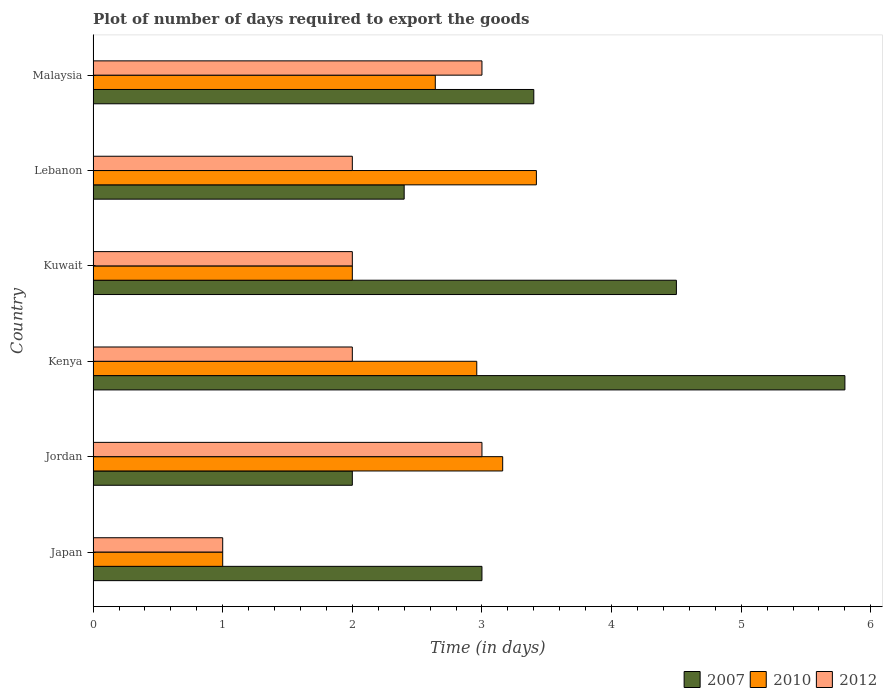Are the number of bars per tick equal to the number of legend labels?
Make the answer very short. Yes. How many bars are there on the 3rd tick from the bottom?
Your answer should be compact. 3. What is the label of the 6th group of bars from the top?
Your answer should be very brief. Japan. What is the time required to export goods in 2012 in Kenya?
Keep it short and to the point. 2. Across all countries, what is the maximum time required to export goods in 2007?
Offer a very short reply. 5.8. Across all countries, what is the minimum time required to export goods in 2007?
Your answer should be compact. 2. In which country was the time required to export goods in 2007 maximum?
Offer a very short reply. Kenya. In which country was the time required to export goods in 2007 minimum?
Offer a terse response. Jordan. What is the total time required to export goods in 2010 in the graph?
Make the answer very short. 15.18. What is the difference between the time required to export goods in 2007 in Kuwait and that in Lebanon?
Your answer should be very brief. 2.1. What is the difference between the time required to export goods in 2012 in Jordan and the time required to export goods in 2010 in Lebanon?
Give a very brief answer. -0.42. What is the average time required to export goods in 2007 per country?
Make the answer very short. 3.52. What is the difference between the time required to export goods in 2010 and time required to export goods in 2007 in Malaysia?
Your response must be concise. -0.76. In how many countries, is the time required to export goods in 2012 greater than 0.8 days?
Your response must be concise. 6. What is the ratio of the time required to export goods in 2007 in Japan to that in Kuwait?
Your answer should be compact. 0.67. Is the difference between the time required to export goods in 2010 in Kenya and Lebanon greater than the difference between the time required to export goods in 2007 in Kenya and Lebanon?
Your answer should be compact. No. What is the difference between the highest and the second highest time required to export goods in 2007?
Give a very brief answer. 1.3. What is the difference between the highest and the lowest time required to export goods in 2010?
Provide a succinct answer. 2.42. What does the 2nd bar from the top in Jordan represents?
Your answer should be very brief. 2010. Is it the case that in every country, the sum of the time required to export goods in 2007 and time required to export goods in 2012 is greater than the time required to export goods in 2010?
Provide a short and direct response. Yes. How many bars are there?
Ensure brevity in your answer.  18. Are all the bars in the graph horizontal?
Your response must be concise. Yes. What is the difference between two consecutive major ticks on the X-axis?
Give a very brief answer. 1. Does the graph contain grids?
Provide a succinct answer. No. Where does the legend appear in the graph?
Keep it short and to the point. Bottom right. What is the title of the graph?
Make the answer very short. Plot of number of days required to export the goods. Does "2008" appear as one of the legend labels in the graph?
Ensure brevity in your answer.  No. What is the label or title of the X-axis?
Provide a succinct answer. Time (in days). What is the label or title of the Y-axis?
Keep it short and to the point. Country. What is the Time (in days) of 2007 in Jordan?
Provide a succinct answer. 2. What is the Time (in days) of 2010 in Jordan?
Give a very brief answer. 3.16. What is the Time (in days) of 2012 in Jordan?
Your response must be concise. 3. What is the Time (in days) of 2007 in Kenya?
Your answer should be very brief. 5.8. What is the Time (in days) in 2010 in Kenya?
Your answer should be very brief. 2.96. What is the Time (in days) of 2010 in Lebanon?
Keep it short and to the point. 3.42. What is the Time (in days) in 2007 in Malaysia?
Keep it short and to the point. 3.4. What is the Time (in days) of 2010 in Malaysia?
Offer a terse response. 2.64. What is the Time (in days) in 2012 in Malaysia?
Offer a terse response. 3. Across all countries, what is the maximum Time (in days) of 2007?
Ensure brevity in your answer.  5.8. Across all countries, what is the maximum Time (in days) of 2010?
Keep it short and to the point. 3.42. Across all countries, what is the minimum Time (in days) of 2010?
Make the answer very short. 1. What is the total Time (in days) in 2007 in the graph?
Your answer should be compact. 21.1. What is the total Time (in days) of 2010 in the graph?
Your response must be concise. 15.18. What is the difference between the Time (in days) of 2010 in Japan and that in Jordan?
Your answer should be very brief. -2.16. What is the difference between the Time (in days) in 2010 in Japan and that in Kenya?
Give a very brief answer. -1.96. What is the difference between the Time (in days) of 2007 in Japan and that in Lebanon?
Ensure brevity in your answer.  0.6. What is the difference between the Time (in days) of 2010 in Japan and that in Lebanon?
Give a very brief answer. -2.42. What is the difference between the Time (in days) in 2012 in Japan and that in Lebanon?
Provide a succinct answer. -1. What is the difference between the Time (in days) in 2010 in Japan and that in Malaysia?
Your answer should be very brief. -1.64. What is the difference between the Time (in days) in 2007 in Jordan and that in Kenya?
Ensure brevity in your answer.  -3.8. What is the difference between the Time (in days) of 2010 in Jordan and that in Kenya?
Offer a terse response. 0.2. What is the difference between the Time (in days) in 2007 in Jordan and that in Kuwait?
Your answer should be very brief. -2.5. What is the difference between the Time (in days) in 2010 in Jordan and that in Kuwait?
Offer a very short reply. 1.16. What is the difference between the Time (in days) of 2007 in Jordan and that in Lebanon?
Provide a succinct answer. -0.4. What is the difference between the Time (in days) in 2010 in Jordan and that in Lebanon?
Offer a very short reply. -0.26. What is the difference between the Time (in days) in 2007 in Jordan and that in Malaysia?
Ensure brevity in your answer.  -1.4. What is the difference between the Time (in days) of 2010 in Jordan and that in Malaysia?
Your answer should be very brief. 0.52. What is the difference between the Time (in days) of 2012 in Jordan and that in Malaysia?
Provide a short and direct response. 0. What is the difference between the Time (in days) of 2010 in Kenya and that in Kuwait?
Offer a very short reply. 0.96. What is the difference between the Time (in days) of 2012 in Kenya and that in Kuwait?
Your answer should be very brief. 0. What is the difference between the Time (in days) of 2007 in Kenya and that in Lebanon?
Give a very brief answer. 3.4. What is the difference between the Time (in days) of 2010 in Kenya and that in Lebanon?
Your answer should be compact. -0.46. What is the difference between the Time (in days) in 2007 in Kenya and that in Malaysia?
Your response must be concise. 2.4. What is the difference between the Time (in days) in 2010 in Kenya and that in Malaysia?
Provide a short and direct response. 0.32. What is the difference between the Time (in days) of 2012 in Kenya and that in Malaysia?
Provide a succinct answer. -1. What is the difference between the Time (in days) of 2010 in Kuwait and that in Lebanon?
Your response must be concise. -1.42. What is the difference between the Time (in days) in 2007 in Kuwait and that in Malaysia?
Your answer should be very brief. 1.1. What is the difference between the Time (in days) of 2010 in Kuwait and that in Malaysia?
Ensure brevity in your answer.  -0.64. What is the difference between the Time (in days) of 2007 in Lebanon and that in Malaysia?
Ensure brevity in your answer.  -1. What is the difference between the Time (in days) in 2010 in Lebanon and that in Malaysia?
Give a very brief answer. 0.78. What is the difference between the Time (in days) in 2012 in Lebanon and that in Malaysia?
Your answer should be compact. -1. What is the difference between the Time (in days) in 2007 in Japan and the Time (in days) in 2010 in Jordan?
Your response must be concise. -0.16. What is the difference between the Time (in days) in 2007 in Japan and the Time (in days) in 2012 in Jordan?
Offer a very short reply. 0. What is the difference between the Time (in days) in 2010 in Japan and the Time (in days) in 2012 in Kenya?
Provide a succinct answer. -1. What is the difference between the Time (in days) of 2007 in Japan and the Time (in days) of 2010 in Kuwait?
Your answer should be very brief. 1. What is the difference between the Time (in days) in 2010 in Japan and the Time (in days) in 2012 in Kuwait?
Offer a very short reply. -1. What is the difference between the Time (in days) of 2007 in Japan and the Time (in days) of 2010 in Lebanon?
Keep it short and to the point. -0.42. What is the difference between the Time (in days) of 2007 in Japan and the Time (in days) of 2010 in Malaysia?
Your response must be concise. 0.36. What is the difference between the Time (in days) in 2007 in Jordan and the Time (in days) in 2010 in Kenya?
Offer a terse response. -0.96. What is the difference between the Time (in days) of 2007 in Jordan and the Time (in days) of 2012 in Kenya?
Your answer should be compact. 0. What is the difference between the Time (in days) in 2010 in Jordan and the Time (in days) in 2012 in Kenya?
Offer a very short reply. 1.16. What is the difference between the Time (in days) of 2007 in Jordan and the Time (in days) of 2010 in Kuwait?
Your answer should be very brief. 0. What is the difference between the Time (in days) in 2010 in Jordan and the Time (in days) in 2012 in Kuwait?
Make the answer very short. 1.16. What is the difference between the Time (in days) of 2007 in Jordan and the Time (in days) of 2010 in Lebanon?
Your response must be concise. -1.42. What is the difference between the Time (in days) in 2007 in Jordan and the Time (in days) in 2012 in Lebanon?
Provide a short and direct response. 0. What is the difference between the Time (in days) in 2010 in Jordan and the Time (in days) in 2012 in Lebanon?
Provide a succinct answer. 1.16. What is the difference between the Time (in days) of 2007 in Jordan and the Time (in days) of 2010 in Malaysia?
Make the answer very short. -0.64. What is the difference between the Time (in days) of 2010 in Jordan and the Time (in days) of 2012 in Malaysia?
Offer a very short reply. 0.16. What is the difference between the Time (in days) of 2007 in Kenya and the Time (in days) of 2010 in Kuwait?
Give a very brief answer. 3.8. What is the difference between the Time (in days) in 2007 in Kenya and the Time (in days) in 2012 in Kuwait?
Make the answer very short. 3.8. What is the difference between the Time (in days) in 2010 in Kenya and the Time (in days) in 2012 in Kuwait?
Ensure brevity in your answer.  0.96. What is the difference between the Time (in days) in 2007 in Kenya and the Time (in days) in 2010 in Lebanon?
Offer a very short reply. 2.38. What is the difference between the Time (in days) of 2010 in Kenya and the Time (in days) of 2012 in Lebanon?
Your response must be concise. 0.96. What is the difference between the Time (in days) in 2007 in Kenya and the Time (in days) in 2010 in Malaysia?
Ensure brevity in your answer.  3.16. What is the difference between the Time (in days) of 2010 in Kenya and the Time (in days) of 2012 in Malaysia?
Offer a very short reply. -0.04. What is the difference between the Time (in days) of 2010 in Kuwait and the Time (in days) of 2012 in Lebanon?
Your answer should be very brief. 0. What is the difference between the Time (in days) of 2007 in Kuwait and the Time (in days) of 2010 in Malaysia?
Your answer should be very brief. 1.86. What is the difference between the Time (in days) of 2010 in Kuwait and the Time (in days) of 2012 in Malaysia?
Offer a very short reply. -1. What is the difference between the Time (in days) of 2007 in Lebanon and the Time (in days) of 2010 in Malaysia?
Ensure brevity in your answer.  -0.24. What is the difference between the Time (in days) of 2007 in Lebanon and the Time (in days) of 2012 in Malaysia?
Provide a succinct answer. -0.6. What is the difference between the Time (in days) in 2010 in Lebanon and the Time (in days) in 2012 in Malaysia?
Offer a very short reply. 0.42. What is the average Time (in days) in 2007 per country?
Keep it short and to the point. 3.52. What is the average Time (in days) of 2010 per country?
Make the answer very short. 2.53. What is the average Time (in days) in 2012 per country?
Provide a short and direct response. 2.17. What is the difference between the Time (in days) in 2007 and Time (in days) in 2010 in Japan?
Your response must be concise. 2. What is the difference between the Time (in days) of 2007 and Time (in days) of 2012 in Japan?
Keep it short and to the point. 2. What is the difference between the Time (in days) in 2010 and Time (in days) in 2012 in Japan?
Make the answer very short. 0. What is the difference between the Time (in days) in 2007 and Time (in days) in 2010 in Jordan?
Make the answer very short. -1.16. What is the difference between the Time (in days) in 2007 and Time (in days) in 2012 in Jordan?
Offer a terse response. -1. What is the difference between the Time (in days) of 2010 and Time (in days) of 2012 in Jordan?
Make the answer very short. 0.16. What is the difference between the Time (in days) of 2007 and Time (in days) of 2010 in Kenya?
Give a very brief answer. 2.84. What is the difference between the Time (in days) of 2010 and Time (in days) of 2012 in Kenya?
Ensure brevity in your answer.  0.96. What is the difference between the Time (in days) in 2007 and Time (in days) in 2010 in Lebanon?
Provide a succinct answer. -1.02. What is the difference between the Time (in days) in 2007 and Time (in days) in 2012 in Lebanon?
Give a very brief answer. 0.4. What is the difference between the Time (in days) of 2010 and Time (in days) of 2012 in Lebanon?
Your answer should be compact. 1.42. What is the difference between the Time (in days) of 2007 and Time (in days) of 2010 in Malaysia?
Your answer should be compact. 0.76. What is the difference between the Time (in days) of 2007 and Time (in days) of 2012 in Malaysia?
Make the answer very short. 0.4. What is the difference between the Time (in days) of 2010 and Time (in days) of 2012 in Malaysia?
Keep it short and to the point. -0.36. What is the ratio of the Time (in days) in 2010 in Japan to that in Jordan?
Your answer should be very brief. 0.32. What is the ratio of the Time (in days) of 2007 in Japan to that in Kenya?
Your answer should be very brief. 0.52. What is the ratio of the Time (in days) in 2010 in Japan to that in Kenya?
Your answer should be very brief. 0.34. What is the ratio of the Time (in days) in 2007 in Japan to that in Kuwait?
Offer a terse response. 0.67. What is the ratio of the Time (in days) in 2010 in Japan to that in Kuwait?
Make the answer very short. 0.5. What is the ratio of the Time (in days) of 2012 in Japan to that in Kuwait?
Give a very brief answer. 0.5. What is the ratio of the Time (in days) of 2010 in Japan to that in Lebanon?
Your answer should be compact. 0.29. What is the ratio of the Time (in days) in 2012 in Japan to that in Lebanon?
Ensure brevity in your answer.  0.5. What is the ratio of the Time (in days) in 2007 in Japan to that in Malaysia?
Give a very brief answer. 0.88. What is the ratio of the Time (in days) in 2010 in Japan to that in Malaysia?
Your response must be concise. 0.38. What is the ratio of the Time (in days) of 2012 in Japan to that in Malaysia?
Keep it short and to the point. 0.33. What is the ratio of the Time (in days) of 2007 in Jordan to that in Kenya?
Provide a short and direct response. 0.34. What is the ratio of the Time (in days) in 2010 in Jordan to that in Kenya?
Your response must be concise. 1.07. What is the ratio of the Time (in days) of 2012 in Jordan to that in Kenya?
Provide a short and direct response. 1.5. What is the ratio of the Time (in days) in 2007 in Jordan to that in Kuwait?
Offer a terse response. 0.44. What is the ratio of the Time (in days) in 2010 in Jordan to that in Kuwait?
Your answer should be compact. 1.58. What is the ratio of the Time (in days) of 2012 in Jordan to that in Kuwait?
Provide a short and direct response. 1.5. What is the ratio of the Time (in days) of 2007 in Jordan to that in Lebanon?
Provide a short and direct response. 0.83. What is the ratio of the Time (in days) in 2010 in Jordan to that in Lebanon?
Give a very brief answer. 0.92. What is the ratio of the Time (in days) in 2012 in Jordan to that in Lebanon?
Ensure brevity in your answer.  1.5. What is the ratio of the Time (in days) of 2007 in Jordan to that in Malaysia?
Provide a succinct answer. 0.59. What is the ratio of the Time (in days) of 2010 in Jordan to that in Malaysia?
Offer a very short reply. 1.2. What is the ratio of the Time (in days) in 2007 in Kenya to that in Kuwait?
Your answer should be compact. 1.29. What is the ratio of the Time (in days) in 2010 in Kenya to that in Kuwait?
Keep it short and to the point. 1.48. What is the ratio of the Time (in days) in 2007 in Kenya to that in Lebanon?
Make the answer very short. 2.42. What is the ratio of the Time (in days) in 2010 in Kenya to that in Lebanon?
Your answer should be very brief. 0.87. What is the ratio of the Time (in days) of 2007 in Kenya to that in Malaysia?
Provide a short and direct response. 1.71. What is the ratio of the Time (in days) of 2010 in Kenya to that in Malaysia?
Ensure brevity in your answer.  1.12. What is the ratio of the Time (in days) in 2007 in Kuwait to that in Lebanon?
Keep it short and to the point. 1.88. What is the ratio of the Time (in days) in 2010 in Kuwait to that in Lebanon?
Offer a very short reply. 0.58. What is the ratio of the Time (in days) in 2007 in Kuwait to that in Malaysia?
Your answer should be very brief. 1.32. What is the ratio of the Time (in days) in 2010 in Kuwait to that in Malaysia?
Your response must be concise. 0.76. What is the ratio of the Time (in days) of 2007 in Lebanon to that in Malaysia?
Provide a succinct answer. 0.71. What is the ratio of the Time (in days) of 2010 in Lebanon to that in Malaysia?
Ensure brevity in your answer.  1.3. What is the ratio of the Time (in days) of 2012 in Lebanon to that in Malaysia?
Make the answer very short. 0.67. What is the difference between the highest and the second highest Time (in days) in 2007?
Offer a very short reply. 1.3. What is the difference between the highest and the second highest Time (in days) of 2010?
Your answer should be compact. 0.26. What is the difference between the highest and the second highest Time (in days) of 2012?
Your response must be concise. 0. What is the difference between the highest and the lowest Time (in days) of 2010?
Keep it short and to the point. 2.42. 